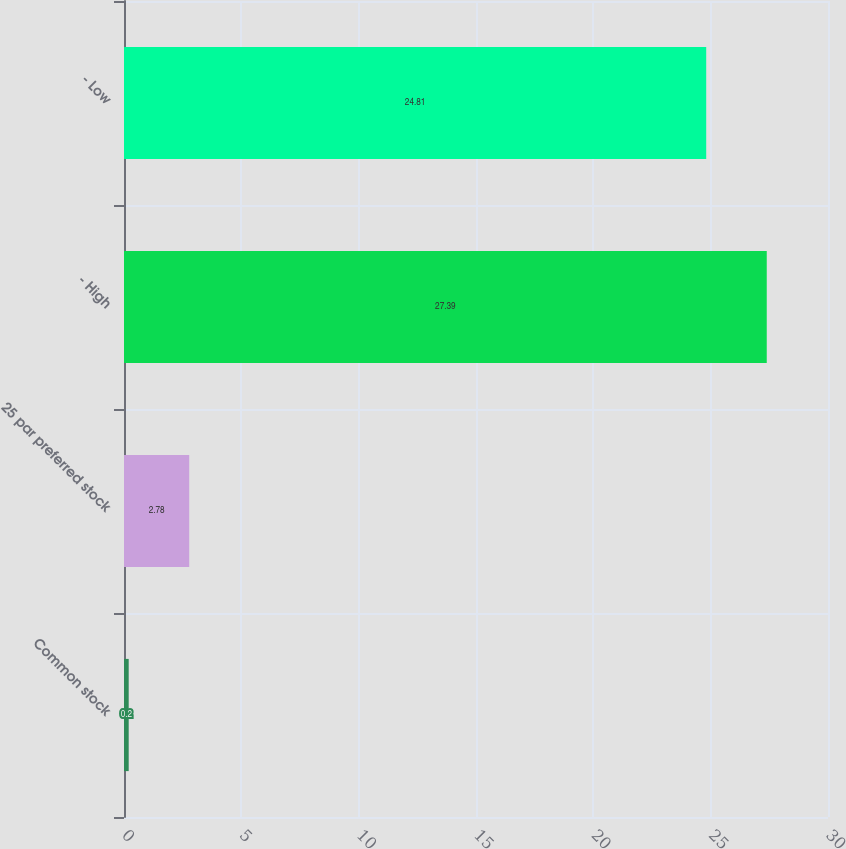<chart> <loc_0><loc_0><loc_500><loc_500><bar_chart><fcel>Common stock<fcel>25 par preferred stock<fcel>- High<fcel>- Low<nl><fcel>0.2<fcel>2.78<fcel>27.39<fcel>24.81<nl></chart> 